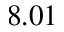<formula> <loc_0><loc_0><loc_500><loc_500>8 . 0 1</formula> 